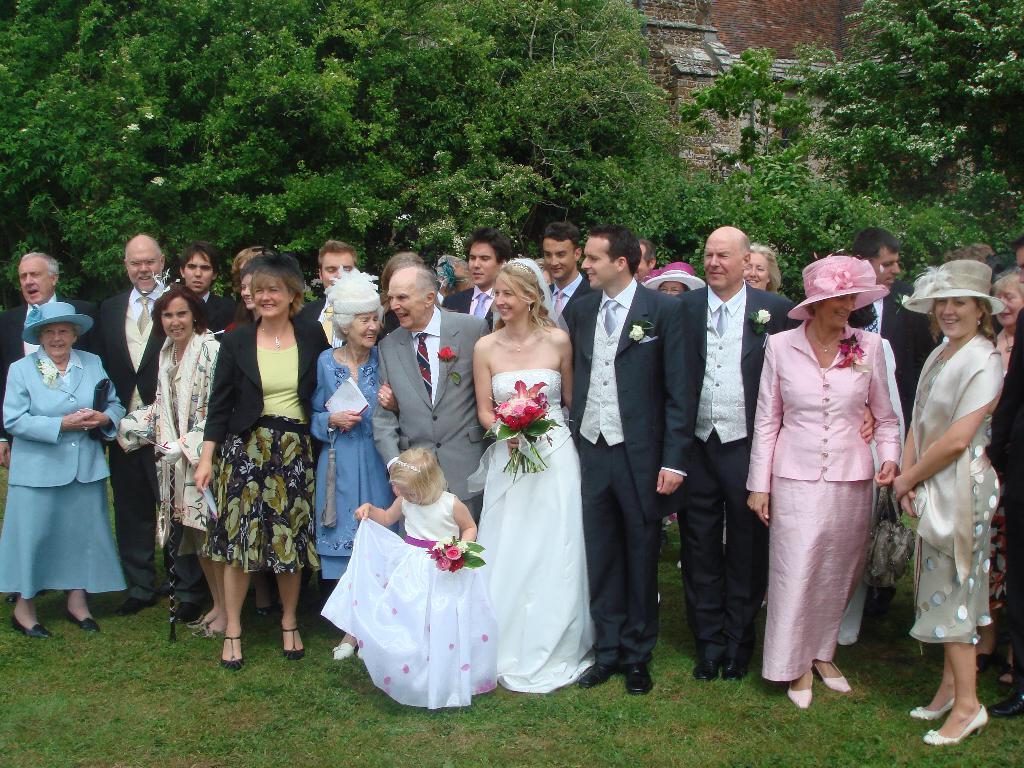Describe this image in one or two sentences. In the foreground of the picture we can see group of people and grass. In the background there are trees and a building. 